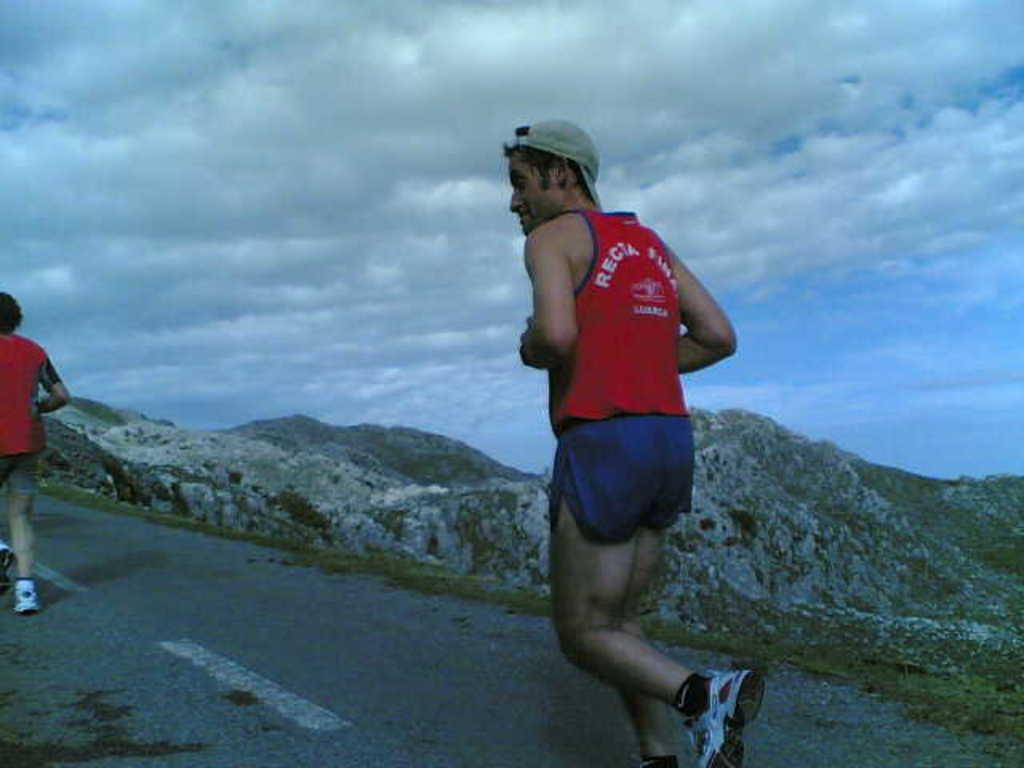How many people are in the image? There are two persons in the image. What are the persons doing in the image? The persons are running on the road. What can be seen in the background of the image? Hills and the sky are visible in the background of the image. What is the condition of the sky in the image? Clouds are present in the sky. What type of print can be seen on the trousers of the person running on the road? There is no information about the trousers or any print on them in the image. Can you tell me how many plantations are visible in the image? There is no mention of plantations in the image; it features two people running on a road with hills and clouds in the background. 